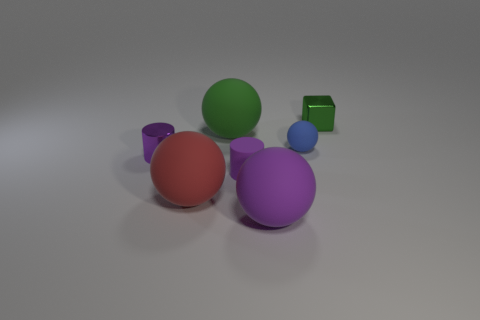What number of things are either tiny green cubes or small purple rubber cylinders?
Make the answer very short. 2. What size is the metallic object behind the small blue rubber object?
Offer a very short reply. Small. How many tiny blue rubber spheres are in front of the tiny metal object that is right of the small shiny object that is in front of the small green shiny thing?
Your response must be concise. 1. Does the shiny cylinder have the same color as the rubber cylinder?
Make the answer very short. Yes. How many objects are both in front of the purple metallic cylinder and left of the big green thing?
Provide a succinct answer. 1. What shape is the purple matte thing that is on the left side of the large purple matte sphere?
Give a very brief answer. Cylinder. Is the number of blue matte things that are in front of the large red rubber thing less than the number of shiny objects on the left side of the tiny green metal block?
Offer a terse response. Yes. Is the material of the green thing on the left side of the small green metallic object the same as the small object that is behind the small ball?
Provide a short and direct response. No. The large green thing has what shape?
Your answer should be compact. Sphere. Are there more tiny things that are in front of the tiny matte sphere than cylinders that are right of the large purple sphere?
Provide a succinct answer. Yes. 